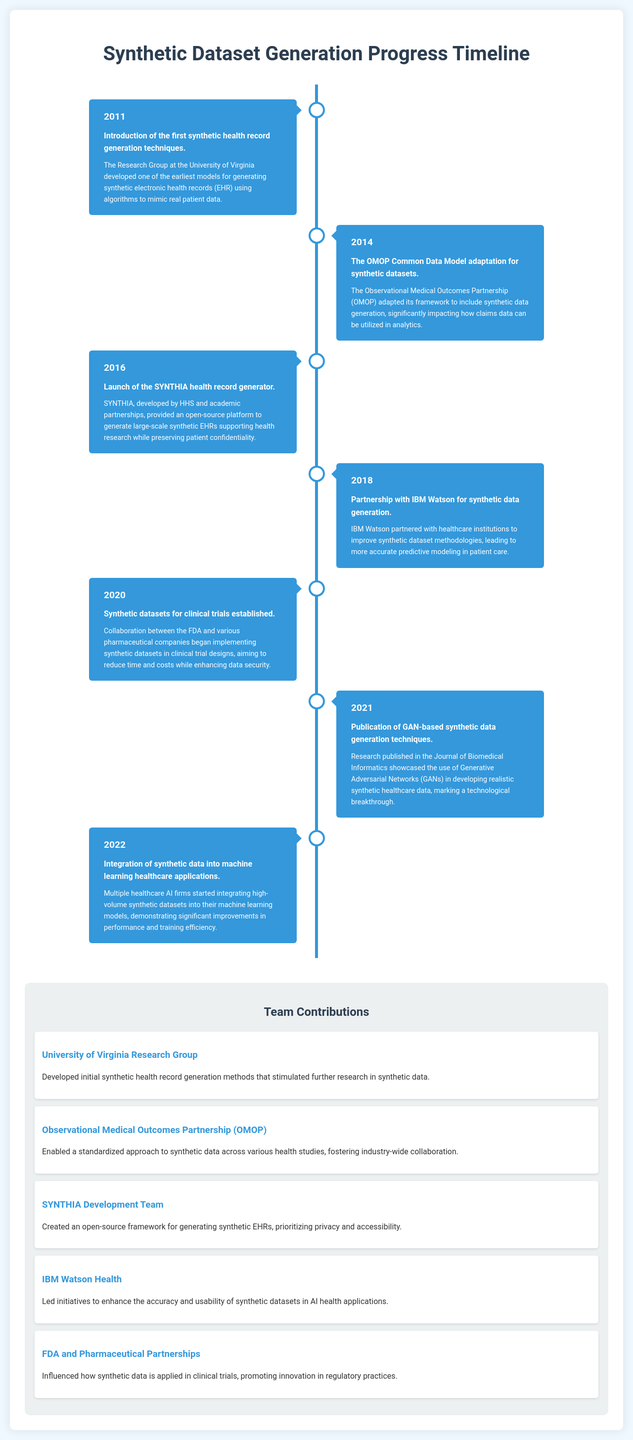What year did the University of Virginia develop synthetic health record generation techniques? The document states that the University of Virginia developed these techniques in 2011.
Answer: 2011 What significant adaptation happened in 2014 related to synthetic datasets? The document mentions the OMOP Common Data Model adaptation for synthetic datasets.
Answer: OMOP Common Data Model adaptation Who partnered with IBM Watson in 2018 for synthetic data generation? The text indicates that IBM Watson partnered with healthcare institutions for improvement in synthetic dataset methodologies.
Answer: Healthcare institutions What breakthrough was published in 2021 regarding synthetic data generation? The document highlights the publication of GAN-based synthetic data generation techniques.
Answer: GAN-based synthetic data generation techniques Which team created an open-source framework for generating synthetic EHRs? The document notes that the SYNTHIA Development Team created this framework.
Answer: SYNTHIA Development Team What is the primary focus of the FDA and pharmaceutical partnerships mentioned in the document? The text describes their impact on how synthetic data is applied in clinical trials.
Answer: Applying synthetic data in clinical trials How many major milestones are covered in the timeline? The timeline has a total of seven milestones listed.
Answer: Seven What notable development took place in 2022 concerning synthetic data? The document states that multiple healthcare AI firms began integrating synthetic datasets into their models in 2022.
Answer: Integration of synthetic data into machine learning healthcare applications 